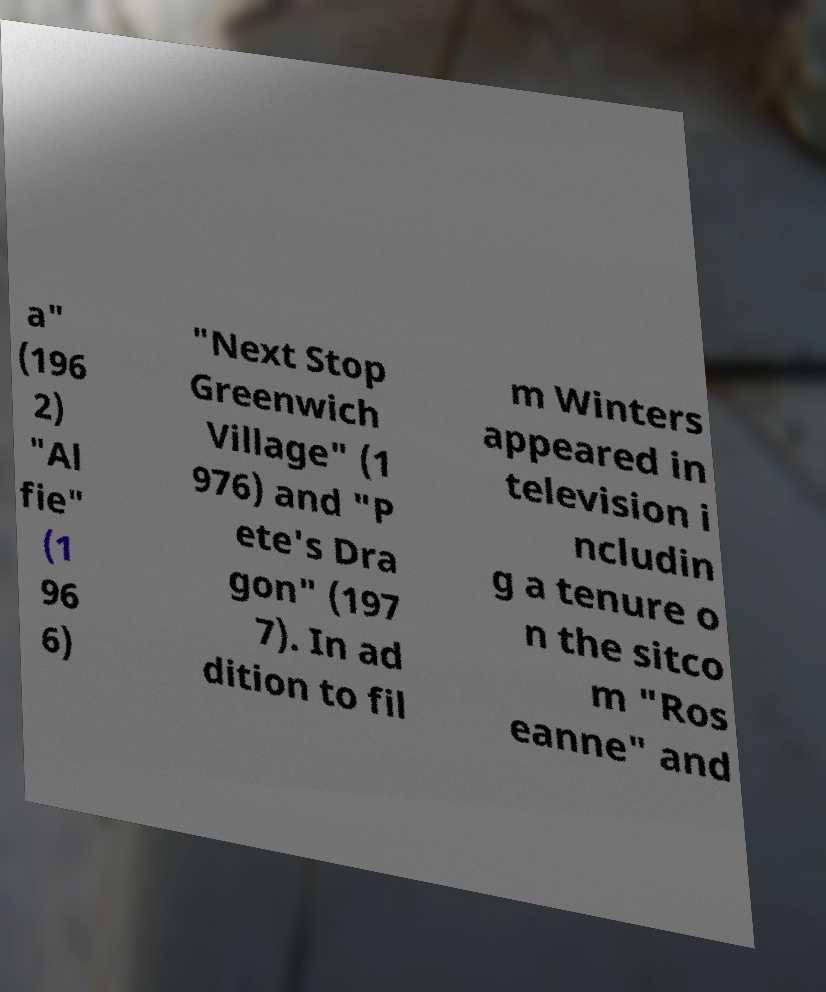I need the written content from this picture converted into text. Can you do that? a" (196 2) "Al fie" (1 96 6) "Next Stop Greenwich Village" (1 976) and "P ete's Dra gon" (197 7). In ad dition to fil m Winters appeared in television i ncludin g a tenure o n the sitco m "Ros eanne" and 